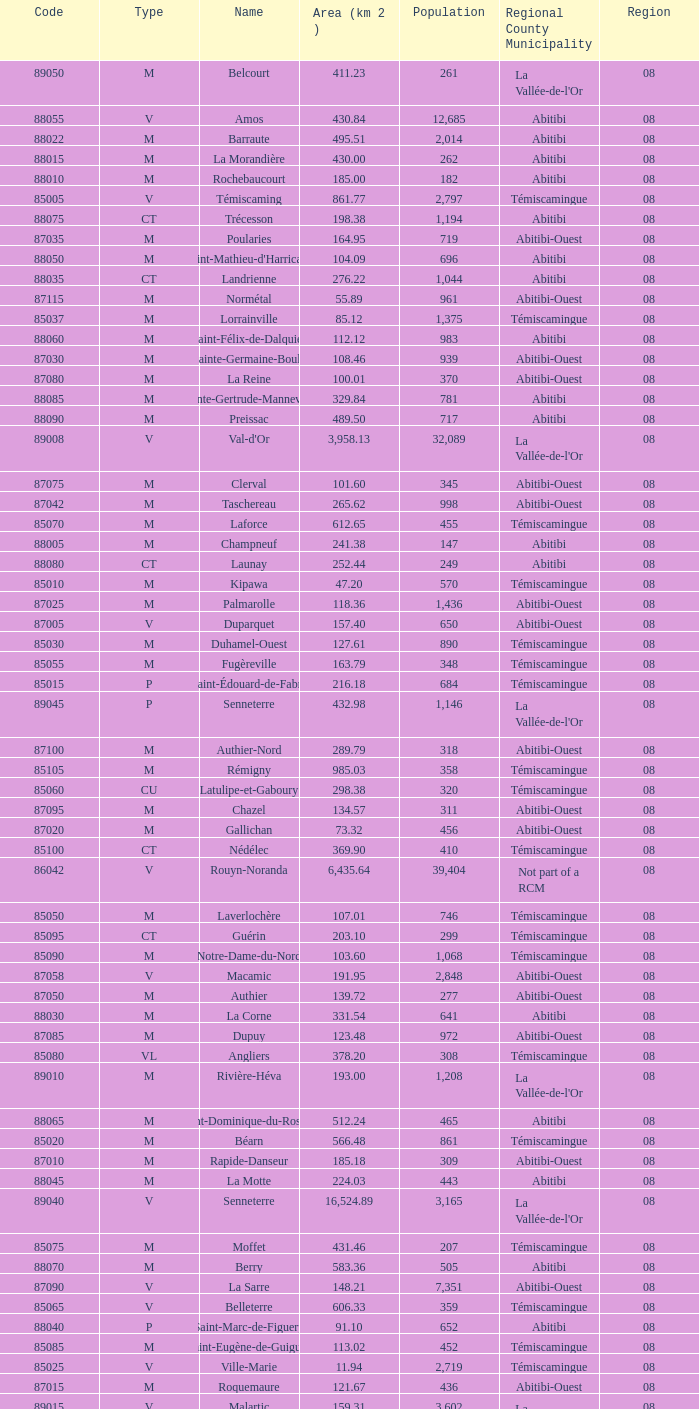Could you parse the entire table? {'header': ['Code', 'Type', 'Name', 'Area (km 2 )', 'Population', 'Regional County Municipality', 'Region'], 'rows': [['89050', 'M', 'Belcourt', '411.23', '261', "La Vallée-de-l'Or", '08'], ['88055', 'V', 'Amos', '430.84', '12,685', 'Abitibi', '08'], ['88022', 'M', 'Barraute', '495.51', '2,014', 'Abitibi', '08'], ['88015', 'M', 'La Morandière', '430.00', '262', 'Abitibi', '08'], ['88010', 'M', 'Rochebaucourt', '185.00', '182', 'Abitibi', '08'], ['85005', 'V', 'Témiscaming', '861.77', '2,797', 'Témiscamingue', '08'], ['88075', 'CT', 'Trécesson', '198.38', '1,194', 'Abitibi', '08'], ['87035', 'M', 'Poularies', '164.95', '719', 'Abitibi-Ouest', '08'], ['88050', 'M', "Saint-Mathieu-d'Harricana", '104.09', '696', 'Abitibi', '08'], ['88035', 'CT', 'Landrienne', '276.22', '1,044', 'Abitibi', '08'], ['87115', 'M', 'Normétal', '55.89', '961', 'Abitibi-Ouest', '08'], ['85037', 'M', 'Lorrainville', '85.12', '1,375', 'Témiscamingue', '08'], ['88060', 'M', 'Saint-Félix-de-Dalquier', '112.12', '983', 'Abitibi', '08'], ['87030', 'M', 'Sainte-Germaine-Boulé', '108.46', '939', 'Abitibi-Ouest', '08'], ['87080', 'M', 'La Reine', '100.01', '370', 'Abitibi-Ouest', '08'], ['88085', 'M', 'Sainte-Gertrude-Manneville', '329.84', '781', 'Abitibi', '08'], ['88090', 'M', 'Preissac', '489.50', '717', 'Abitibi', '08'], ['89008', 'V', "Val-d'Or", '3,958.13', '32,089', "La Vallée-de-l'Or", '08'], ['87075', 'M', 'Clerval', '101.60', '345', 'Abitibi-Ouest', '08'], ['87042', 'M', 'Taschereau', '265.62', '998', 'Abitibi-Ouest', '08'], ['85070', 'M', 'Laforce', '612.65', '455', 'Témiscamingue', '08'], ['88005', 'M', 'Champneuf', '241.38', '147', 'Abitibi', '08'], ['88080', 'CT', 'Launay', '252.44', '249', 'Abitibi', '08'], ['85010', 'M', 'Kipawa', '47.20', '570', 'Témiscamingue', '08'], ['87025', 'M', 'Palmarolle', '118.36', '1,436', 'Abitibi-Ouest', '08'], ['87005', 'V', 'Duparquet', '157.40', '650', 'Abitibi-Ouest', '08'], ['85030', 'M', 'Duhamel-Ouest', '127.61', '890', 'Témiscamingue', '08'], ['85055', 'M', 'Fugèreville', '163.79', '348', 'Témiscamingue', '08'], ['85015', 'P', 'Saint-Édouard-de-Fabre', '216.18', '684', 'Témiscamingue', '08'], ['89045', 'P', 'Senneterre', '432.98', '1,146', "La Vallée-de-l'Or", '08'], ['87100', 'M', 'Authier-Nord', '289.79', '318', 'Abitibi-Ouest', '08'], ['85105', 'M', 'Rémigny', '985.03', '358', 'Témiscamingue', '08'], ['85060', 'CU', 'Latulipe-et-Gaboury', '298.38', '320', 'Témiscamingue', '08'], ['87095', 'M', 'Chazel', '134.57', '311', 'Abitibi-Ouest', '08'], ['87020', 'M', 'Gallichan', '73.32', '456', 'Abitibi-Ouest', '08'], ['85100', 'CT', 'Nédélec', '369.90', '410', 'Témiscamingue', '08'], ['86042', 'V', 'Rouyn-Noranda', '6,435.64', '39,404', 'Not part of a RCM', '08'], ['85050', 'M', 'Laverlochère', '107.01', '746', 'Témiscamingue', '08'], ['85095', 'CT', 'Guérin', '203.10', '299', 'Témiscamingue', '08'], ['85090', 'M', 'Notre-Dame-du-Nord', '103.60', '1,068', 'Témiscamingue', '08'], ['87058', 'V', 'Macamic', '191.95', '2,848', 'Abitibi-Ouest', '08'], ['87050', 'M', 'Authier', '139.72', '277', 'Abitibi-Ouest', '08'], ['88030', 'M', 'La Corne', '331.54', '641', 'Abitibi', '08'], ['87085', 'M', 'Dupuy', '123.48', '972', 'Abitibi-Ouest', '08'], ['85080', 'VL', 'Angliers', '378.20', '308', 'Témiscamingue', '08'], ['89010', 'M', 'Rivière-Héva', '193.00', '1,208', "La Vallée-de-l'Or", '08'], ['88065', 'M', 'Saint-Dominique-du-Rosaire', '512.24', '465', 'Abitibi', '08'], ['85020', 'M', 'Béarn', '566.48', '861', 'Témiscamingue', '08'], ['87010', 'M', 'Rapide-Danseur', '185.18', '309', 'Abitibi-Ouest', '08'], ['88045', 'M', 'La Motte', '224.03', '443', 'Abitibi', '08'], ['89040', 'V', 'Senneterre', '16,524.89', '3,165', "La Vallée-de-l'Or", '08'], ['85075', 'M', 'Moffet', '431.46', '207', 'Témiscamingue', '08'], ['88070', 'M', 'Berry', '583.36', '505', 'Abitibi', '08'], ['87090', 'V', 'La Sarre', '148.21', '7,351', 'Abitibi-Ouest', '08'], ['85065', 'V', 'Belleterre', '606.33', '359', 'Témiscamingue', '08'], ['88040', 'P', 'Saint-Marc-de-Figuery', '91.10', '652', 'Abitibi', '08'], ['85085', 'M', 'Saint-Eugène-de-Guigues', '113.02', '452', 'Témiscamingue', '08'], ['85025', 'V', 'Ville-Marie', '11.94', '2,719', 'Témiscamingue', '08'], ['87015', 'M', 'Roquemaure', '121.67', '436', 'Abitibi-Ouest', '08'], ['89015', 'V', 'Malartic', '159.31', '3,602', "La Vallée-de-l'Or", '08'], ['87120', 'P', 'Saint-Lambert', '101.76', '228', 'Abitibi-Ouest', '08'], ['87070', 'P', 'Sainte-Hélène-de-Mancebourg', '68.29', '374', 'Abitibi-Ouest', '08'], ['85045', 'M', 'Saint-Bruno-de-Guigues', '188.99', '1,095', 'Témiscamingue', '08'], ['87105', 'M', 'Val-Saint-Gilles', '110.54', '159', 'Abitibi-Ouest', '08'], ['87110', 'CT', 'Clermont', '155.89', '568', 'Abitibi-Ouest', '08']]} What was the region for Malartic with 159.31 km2? 0.0. 